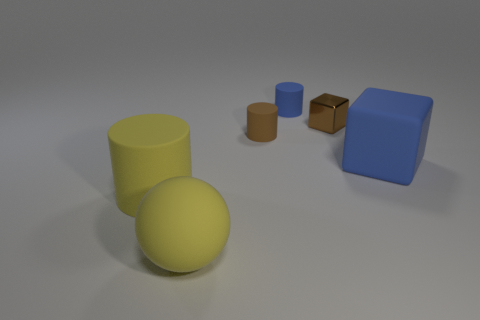There is a tiny rubber thing that is the same color as the rubber cube; what is its shape?
Your response must be concise. Cylinder. Is there a tiny matte object that has the same color as the metallic block?
Your answer should be very brief. Yes. There is a matte thing that is the same color as the ball; what size is it?
Ensure brevity in your answer.  Large. The blue matte object that is in front of the small shiny block in front of the tiny cylinder to the right of the brown rubber thing is what shape?
Your answer should be very brief. Cube. Is the size of the yellow rubber sphere the same as the brown matte object?
Your answer should be compact. No. How many objects are either big yellow balls or rubber objects that are left of the tiny shiny block?
Ensure brevity in your answer.  4. What number of things are either large objects in front of the small blue rubber thing or small blue objects that are on the right side of the large yellow matte sphere?
Ensure brevity in your answer.  4. There is a tiny blue cylinder; are there any blue matte things on the right side of it?
Your answer should be very brief. Yes. The large thing in front of the large rubber thing that is on the left side of the large yellow rubber object right of the yellow cylinder is what color?
Your response must be concise. Yellow. Is the shape of the small blue rubber thing the same as the large blue object?
Your answer should be compact. No. 